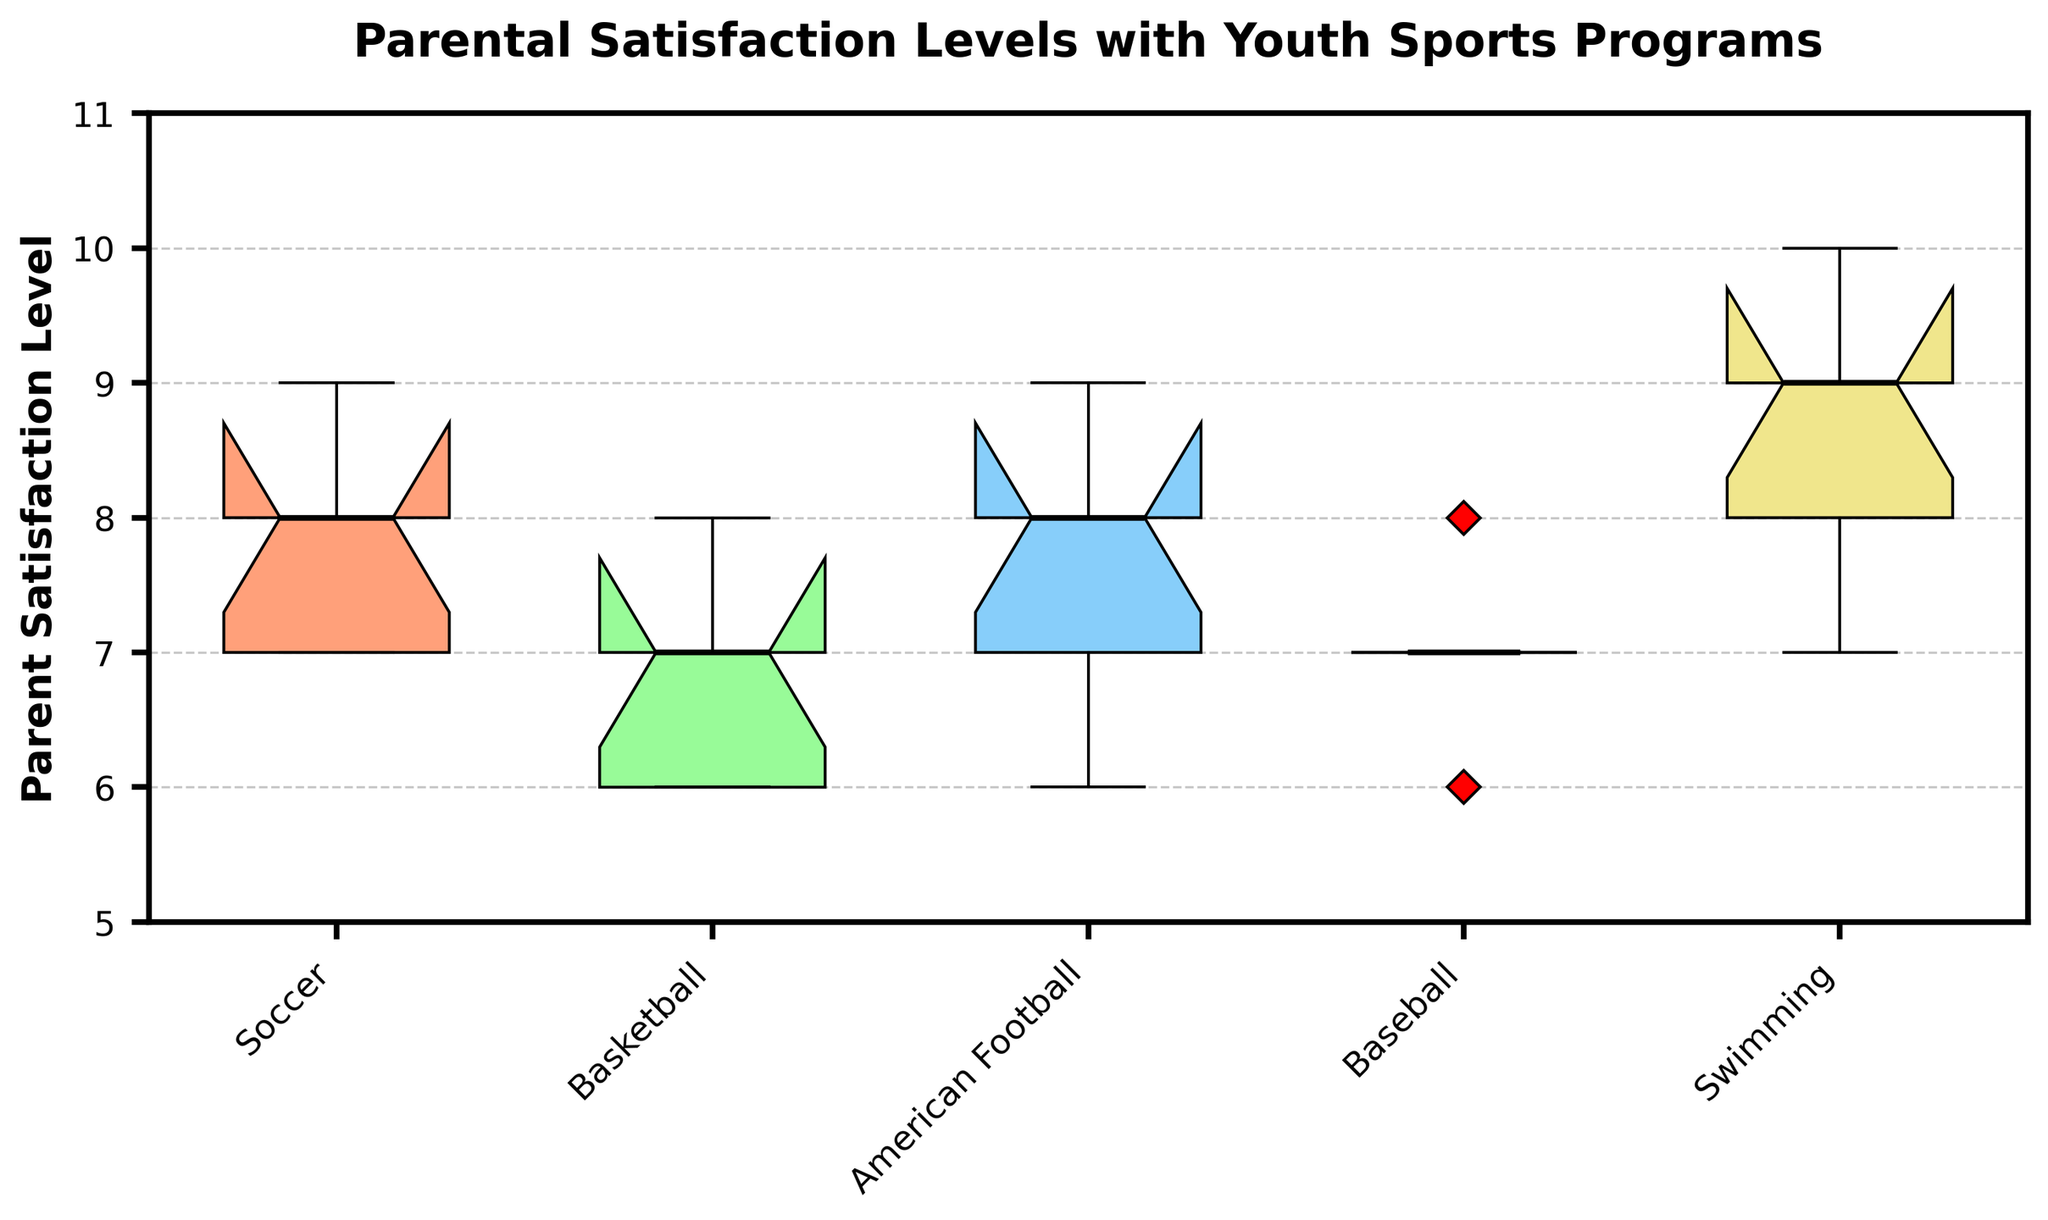What is the title of the plot? The title is located at the top of the plot and summarizes the displayed data.
Answer: Parental Satisfaction Levels with Youth Sports Programs What is the range of the Parent Satisfaction Level axis? The y-axis represents the range of parent satisfaction levels, which can be identified by its labels.
Answer: 5 to 11 Which sport has the highest median satisfaction level? The median is marked by the black line within each box. The highest median line is found in the box corresponding to Swimming.
Answer: Swimming What color is used for the American Football box? The plot uses distinct colors for each sport's box plot. The one with the color corresponding to American Football should be identified.
Answer: Light Purple Which sport has the widest interquartile range (IQR)? The IQR is determined by the height of the box. The sport with the tallest box (distance between the lower and upper quartile) needs to be identified.
Answer: American Football How does the median satisfaction level for Baseball compare to Soccer? By looking at the median lines within the boxes for each sport, compare the heights of the median lines for Baseball and Soccer.
Answer: Baseball's median is slightly lower than Soccer's median What is the approximate lower quartile value for Basketball? The lower quartile (Q1) is marked by the bottom line of the box. Approximate its value by locating it on the y-axis.
Answer: 6 Which sport has the most outliers and how many? Outliers are marked by red diamonds outside the boxes. The sport with the most red diamonds, along with their count, should be detailed.
Answer: Swimming, 1 Are the notches of the American Football box plot overlapping with any other sports? The notches are represented by the indented regions on the sides of each box. Check if the notches for American Football intersect with those of other sports.
Answer: No What insight can be drawn about overall parental satisfaction across these youth sports programs? By observing overall patterns such as median values, IQR, and outliers among the boxes, one can summarize satisfaction trends across the sports.
Answer: Swimming has the highest median satisfaction, American Football and Soccer both have relatively high medians but varying IQRs. Generally, satisfaction levels are high among these sports 